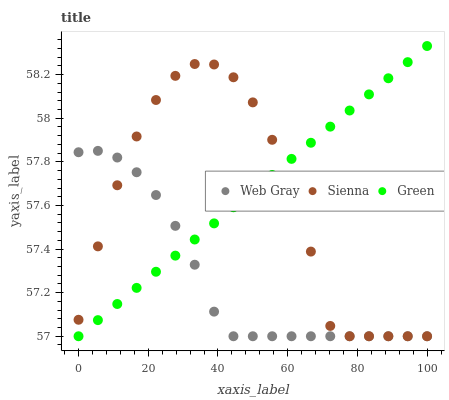Does Web Gray have the minimum area under the curve?
Answer yes or no. Yes. Does Green have the maximum area under the curve?
Answer yes or no. Yes. Does Green have the minimum area under the curve?
Answer yes or no. No. Does Web Gray have the maximum area under the curve?
Answer yes or no. No. Is Green the smoothest?
Answer yes or no. Yes. Is Sienna the roughest?
Answer yes or no. Yes. Is Web Gray the smoothest?
Answer yes or no. No. Is Web Gray the roughest?
Answer yes or no. No. Does Sienna have the lowest value?
Answer yes or no. Yes. Does Green have the highest value?
Answer yes or no. Yes. Does Web Gray have the highest value?
Answer yes or no. No. Does Web Gray intersect Sienna?
Answer yes or no. Yes. Is Web Gray less than Sienna?
Answer yes or no. No. Is Web Gray greater than Sienna?
Answer yes or no. No. 